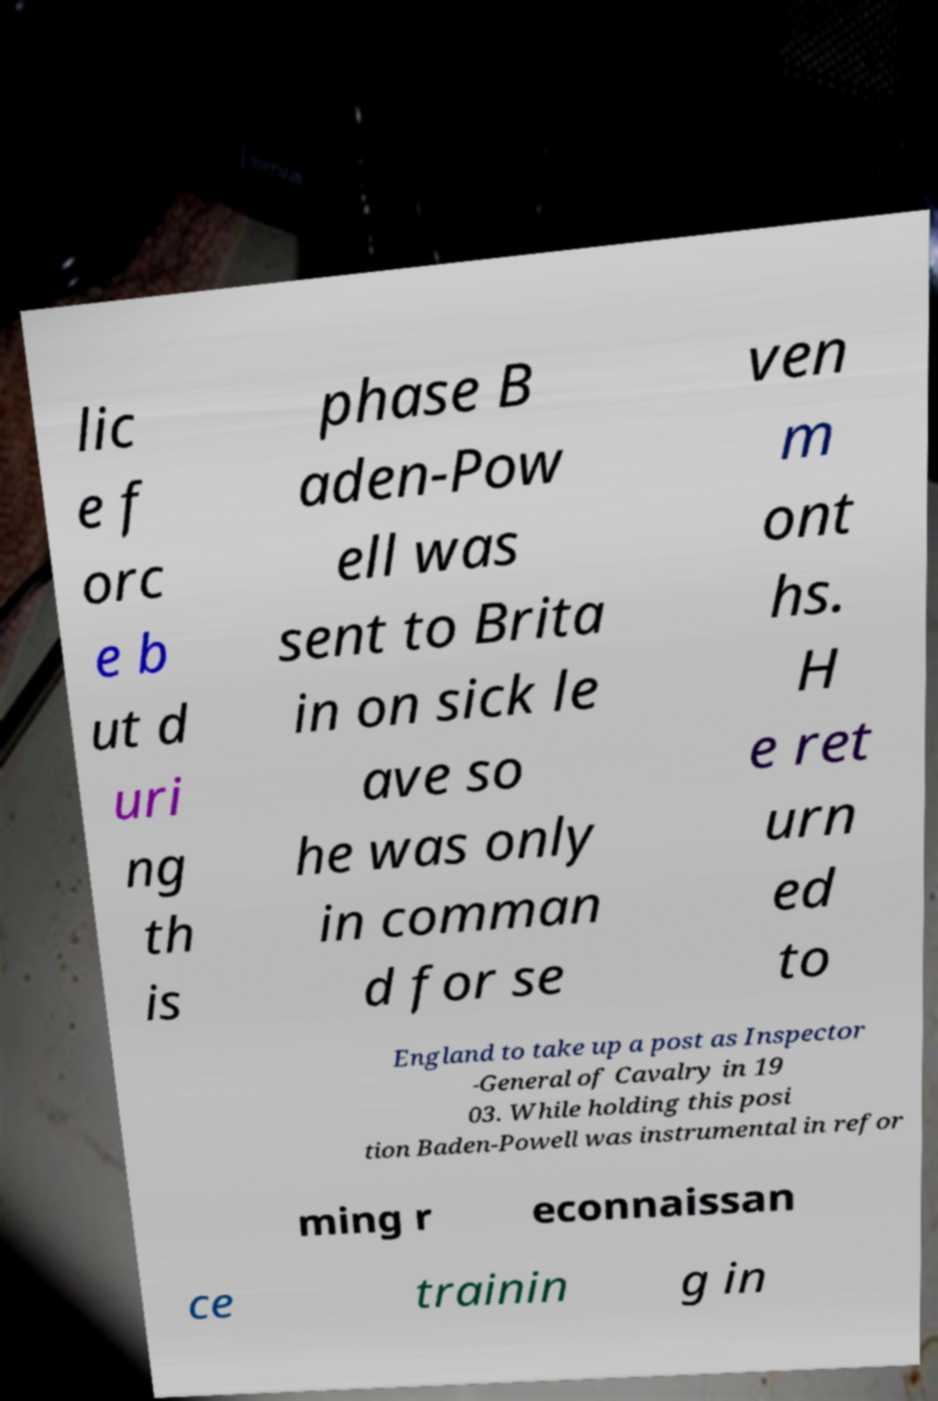Could you assist in decoding the text presented in this image and type it out clearly? lic e f orc e b ut d uri ng th is phase B aden-Pow ell was sent to Brita in on sick le ave so he was only in comman d for se ven m ont hs. H e ret urn ed to England to take up a post as Inspector -General of Cavalry in 19 03. While holding this posi tion Baden-Powell was instrumental in refor ming r econnaissan ce trainin g in 